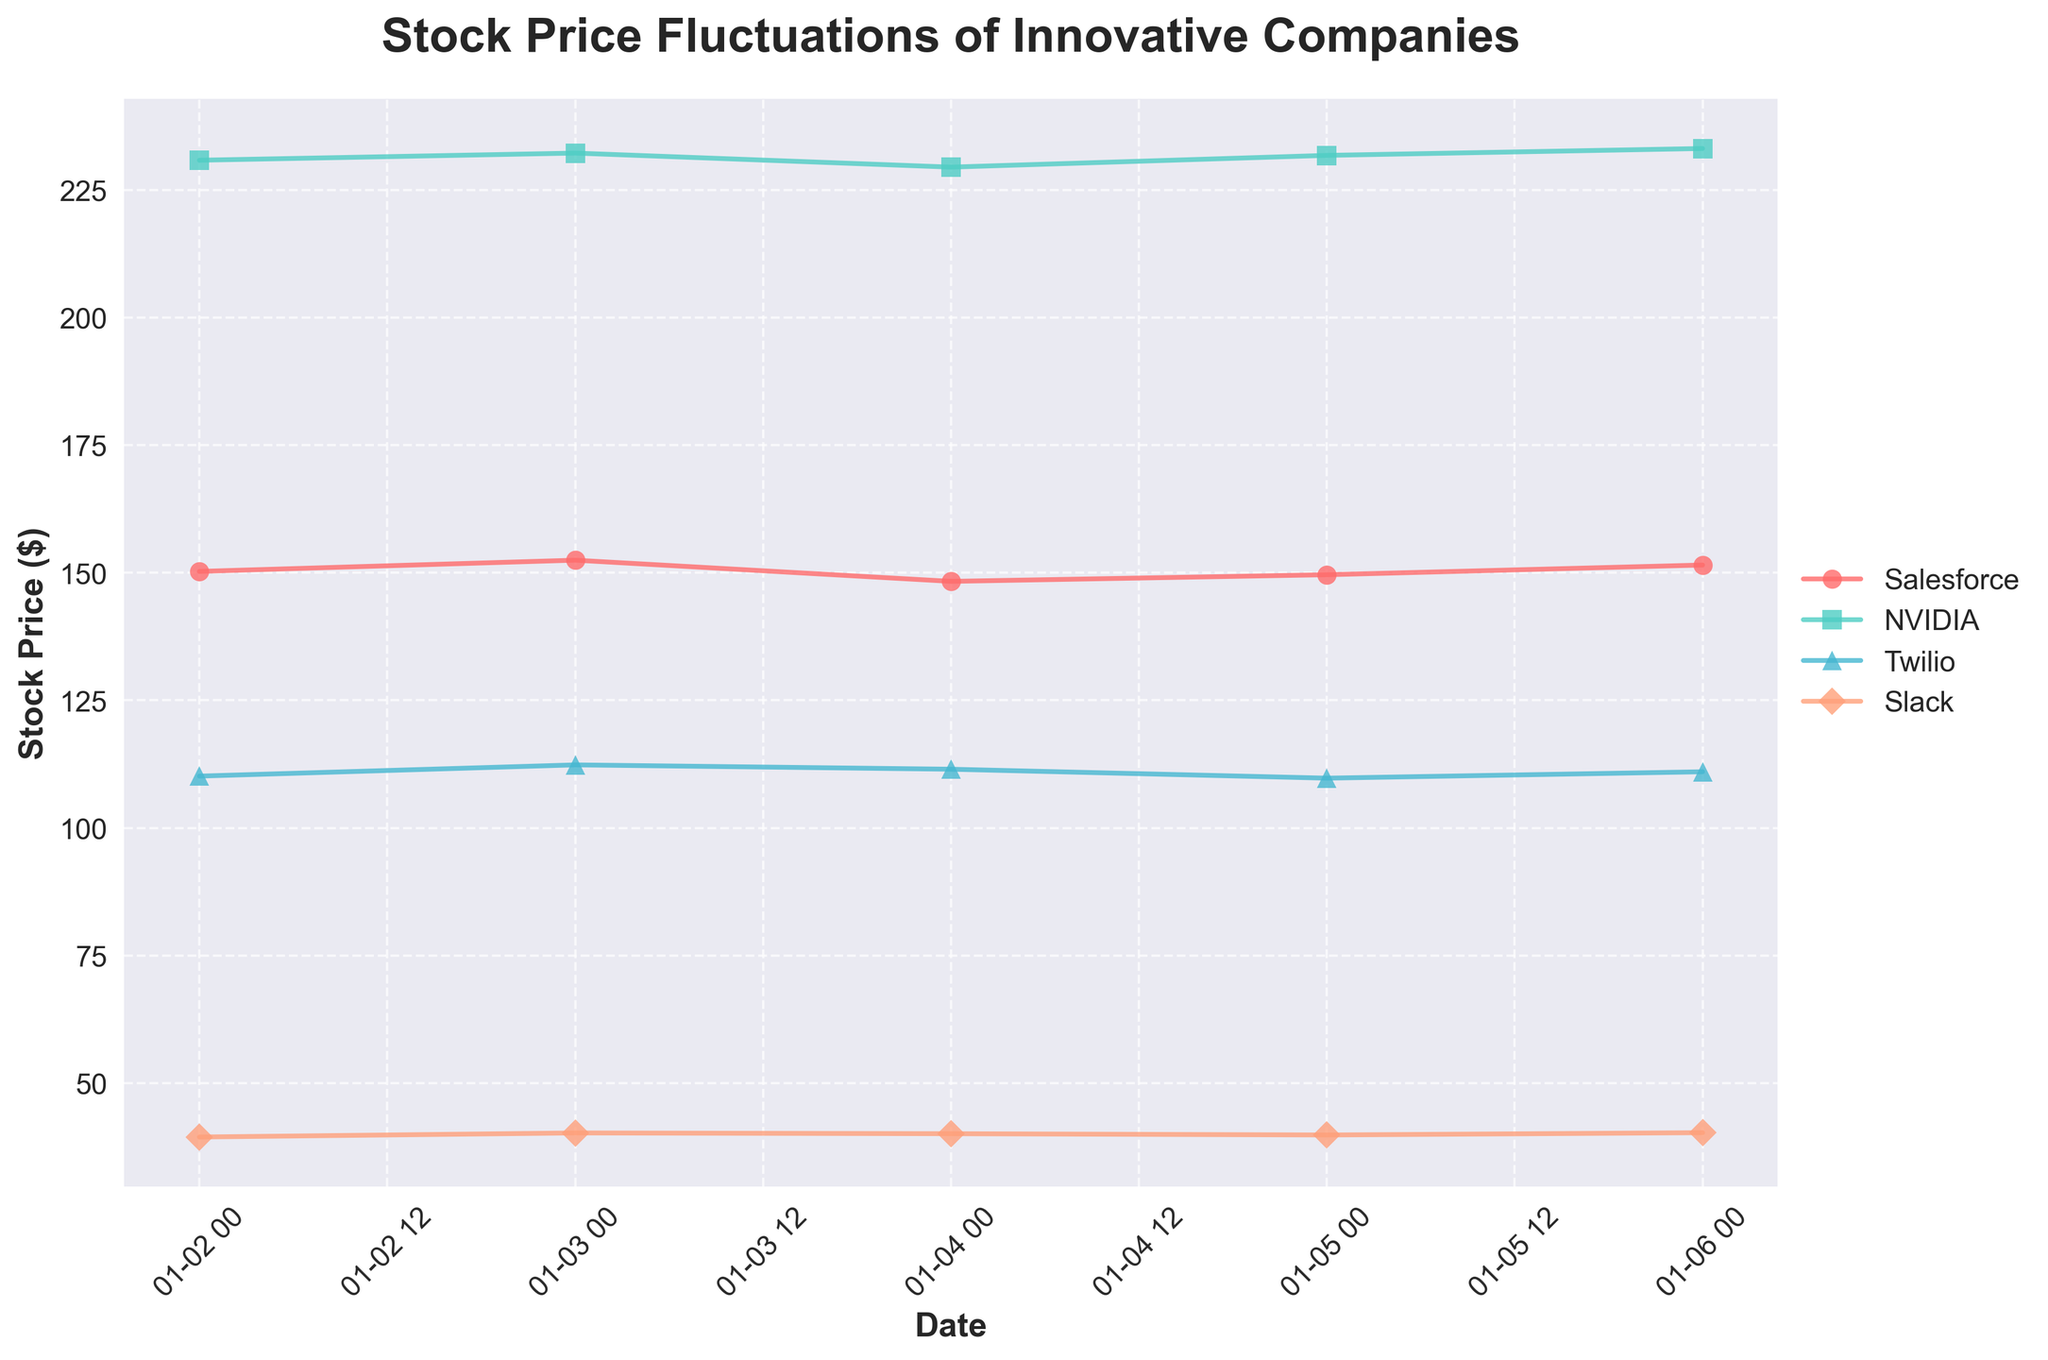What is the title of the figure? The title is usually located at the top of the figure and provides a summary of what the figure represents. In this figure, the title is "Stock Price Fluctuations of Innovative Companies".
Answer: Stock Price Fluctuations of Innovative Companies How does Twilio's stock price on January 6 compare to its stock price on January 5? To determine this, locate Twilio's stock prices on January 5 and January 6 on the plot and compare them. Twilio's stock price on January 6 is higher than on January 5.
Answer: Higher Which company has the largest range of stock prices over the period shown? To find this, calculate the difference between the maximum and minimum stock prices for each company and compare these ranges. NVIDIA has the largest range, from $229.45 to $233.10.
Answer: NVIDIA Which company has the highest stock price on January 4? Find the stock prices for each company on January 4 and identify the highest one. NVIDIA has the highest stock price on January 4 at $229.45.
Answer: NVIDIA What is the average stock price of Salesforce for the given dates? Add all the stock prices of Salesforce and divide by the number of dates. The average is (150.25 + 152.45 + 148.30 + 149.60 + 151.50) / 5 = 150.42.
Answer: 150.42 What is the trend in Slack's stock price over the given dates? Observe the stock prices of Slack from January 2 to January 6 to identify the overall pattern. Slack's stock price shows a slight increase over the period.
Answer: Increasing Which company had the most consistent stock prices over the period? To find the most consistent stock prices, look for the company with the smallest variation in stock prices. Salesforce shows less fluctuation compared to others.
Answer: Salesforce What is the closing stock price of Salesforce on January 3? Locate Salesforce's stock price on January 3 on the figure. The closing price is $152.45.
Answer: 152.45 Compare the highest stock price of Twilio and Slack over the given dates. Which is higher? Identify the highest stock price for Twilio and Slack respectively from the plot and compare them. Slack's highest stock price is $40.30, which is lower than Twilio's highest at $112.35.
Answer: Twilio's is higher Which company showed an increase in stock price every day? Check the stock prices day by day for each company to see if any of them increased every day. None of the companies showed an increase every day.
Answer: None 